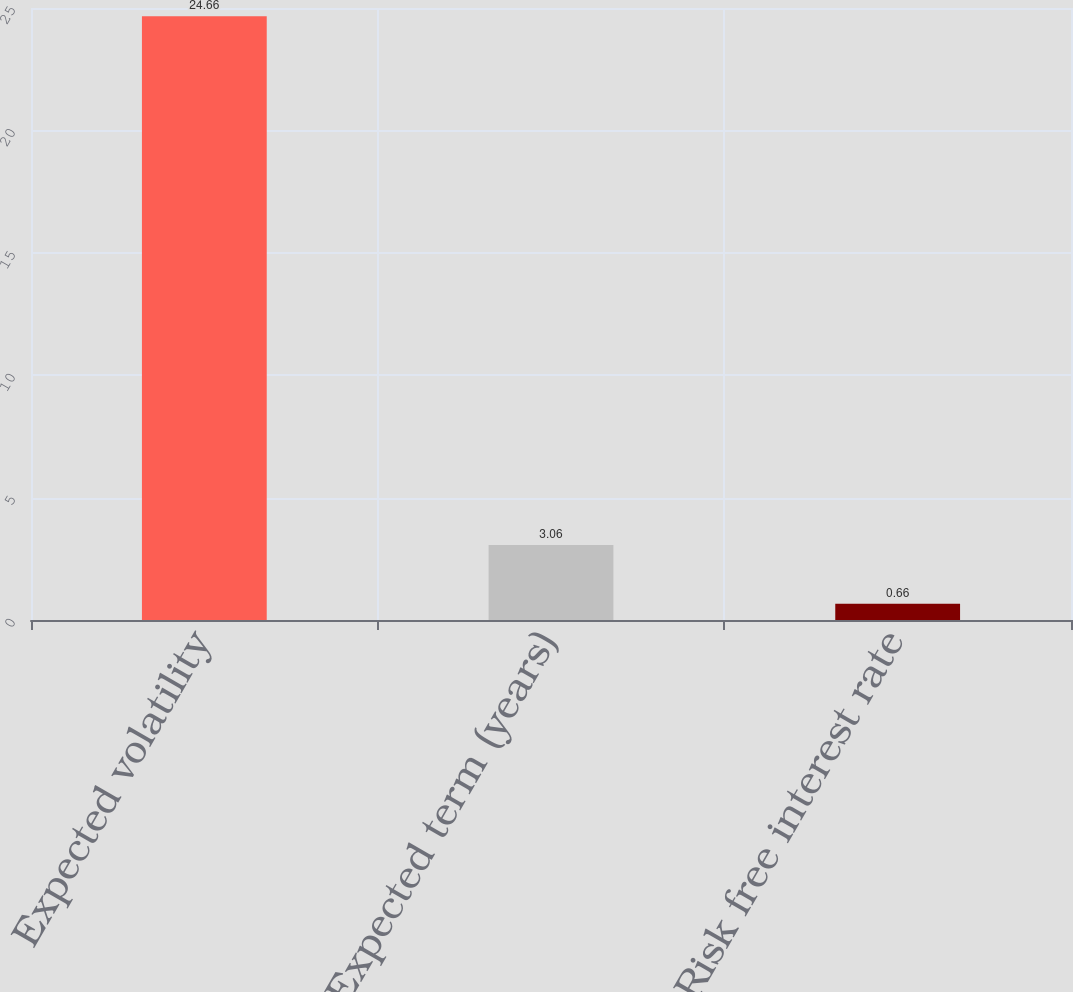Convert chart. <chart><loc_0><loc_0><loc_500><loc_500><bar_chart><fcel>Expected volatility<fcel>Expected term (years)<fcel>Risk free interest rate<nl><fcel>24.66<fcel>3.06<fcel>0.66<nl></chart> 